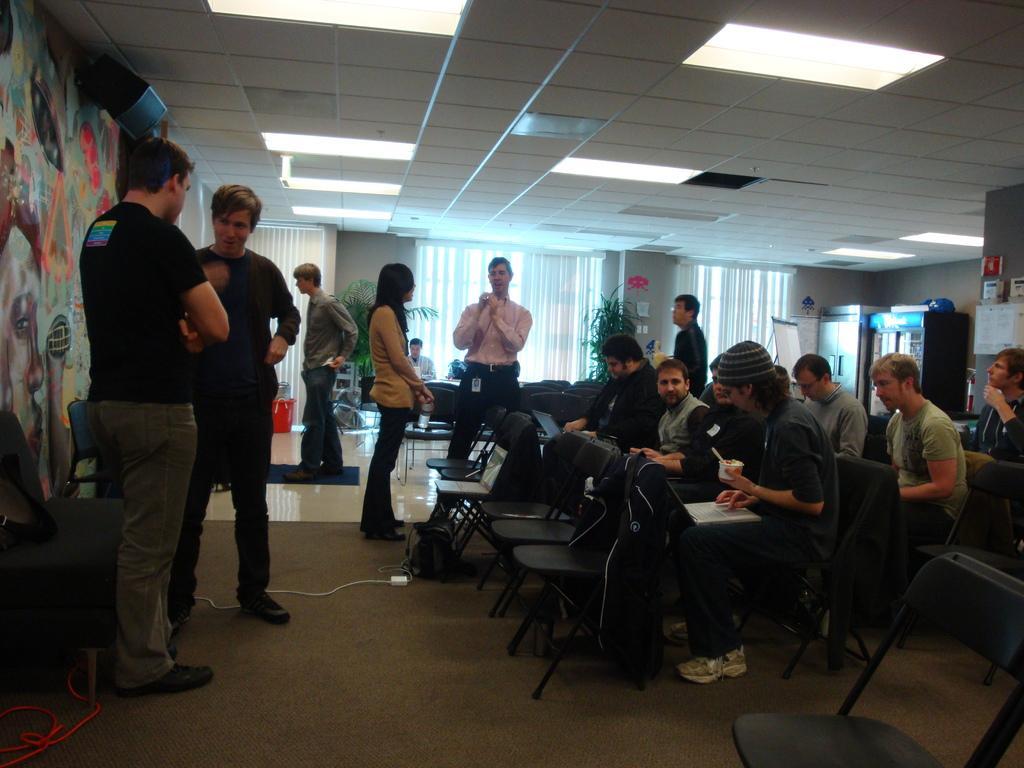Describe this image in one or two sentences. There are group of people sitting on the chair and few standing on the roof. In the background we can see cupboards,curtain,water plant,window. On the rooftop there are lights. 